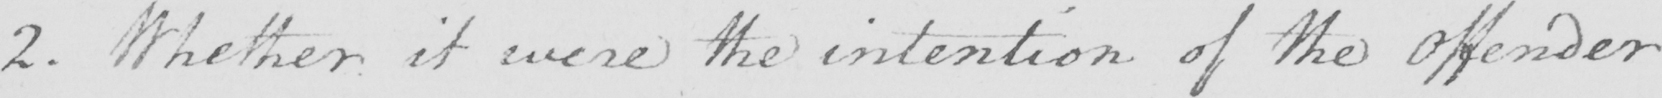Please provide the text content of this handwritten line. 2 . Whether it were the intention of the offender 